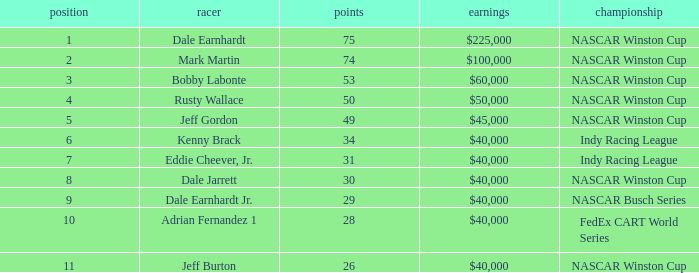How much did Kenny Brack win? $40,000. 